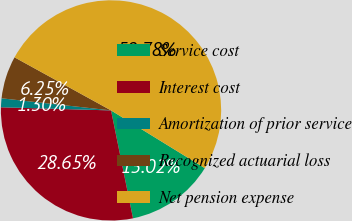Convert chart. <chart><loc_0><loc_0><loc_500><loc_500><pie_chart><fcel>Service cost<fcel>Interest cost<fcel>Amortization of prior service<fcel>Recognized actuarial loss<fcel>Net pension expense<nl><fcel>13.02%<fcel>28.65%<fcel>1.3%<fcel>6.25%<fcel>50.78%<nl></chart> 